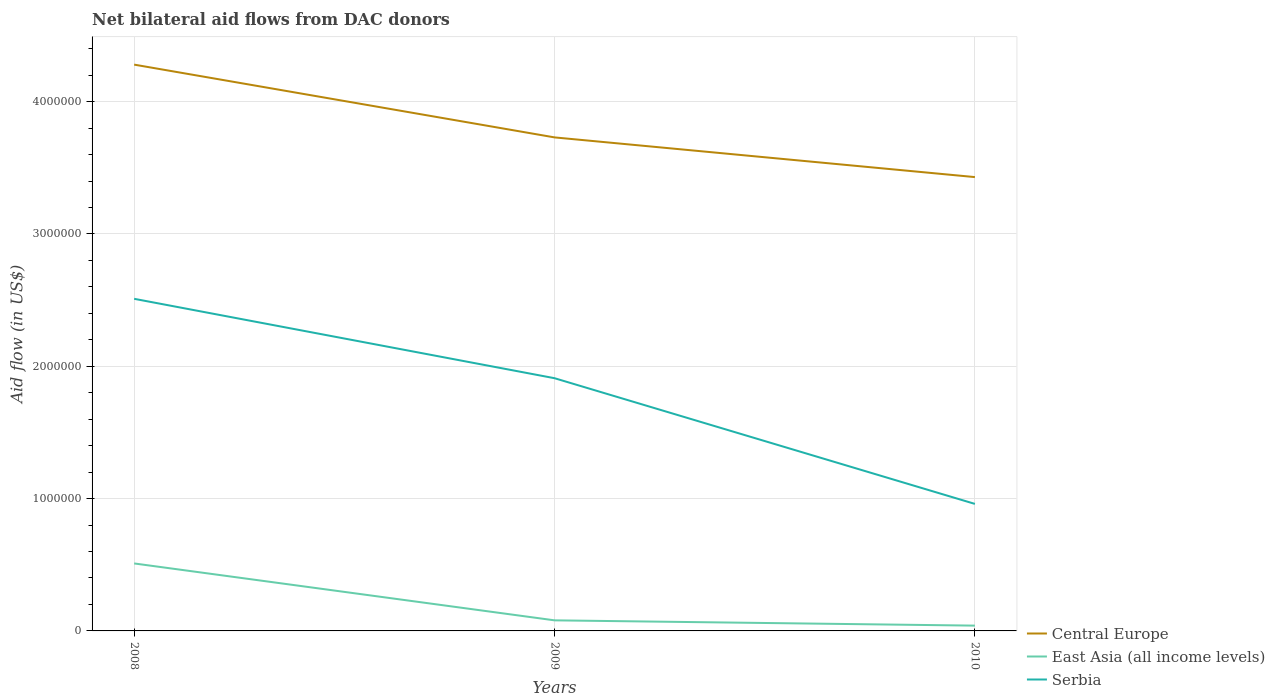Does the line corresponding to Serbia intersect with the line corresponding to Central Europe?
Your answer should be compact. No. Is the number of lines equal to the number of legend labels?
Your answer should be very brief. Yes. Across all years, what is the maximum net bilateral aid flow in Central Europe?
Provide a short and direct response. 3.43e+06. What is the total net bilateral aid flow in East Asia (all income levels) in the graph?
Provide a succinct answer. 4.30e+05. What is the difference between the highest and the second highest net bilateral aid flow in Central Europe?
Your response must be concise. 8.50e+05. How many lines are there?
Provide a succinct answer. 3. How many years are there in the graph?
Ensure brevity in your answer.  3. Are the values on the major ticks of Y-axis written in scientific E-notation?
Offer a terse response. No. Does the graph contain grids?
Your answer should be compact. Yes. What is the title of the graph?
Provide a succinct answer. Net bilateral aid flows from DAC donors. Does "Suriname" appear as one of the legend labels in the graph?
Offer a terse response. No. What is the label or title of the X-axis?
Offer a terse response. Years. What is the label or title of the Y-axis?
Ensure brevity in your answer.  Aid flow (in US$). What is the Aid flow (in US$) in Central Europe in 2008?
Offer a terse response. 4.28e+06. What is the Aid flow (in US$) of East Asia (all income levels) in 2008?
Your answer should be very brief. 5.10e+05. What is the Aid flow (in US$) of Serbia in 2008?
Ensure brevity in your answer.  2.51e+06. What is the Aid flow (in US$) of Central Europe in 2009?
Your answer should be very brief. 3.73e+06. What is the Aid flow (in US$) of East Asia (all income levels) in 2009?
Offer a very short reply. 8.00e+04. What is the Aid flow (in US$) in Serbia in 2009?
Keep it short and to the point. 1.91e+06. What is the Aid flow (in US$) of Central Europe in 2010?
Keep it short and to the point. 3.43e+06. What is the Aid flow (in US$) in East Asia (all income levels) in 2010?
Offer a very short reply. 4.00e+04. What is the Aid flow (in US$) of Serbia in 2010?
Offer a very short reply. 9.60e+05. Across all years, what is the maximum Aid flow (in US$) of Central Europe?
Provide a succinct answer. 4.28e+06. Across all years, what is the maximum Aid flow (in US$) of East Asia (all income levels)?
Ensure brevity in your answer.  5.10e+05. Across all years, what is the maximum Aid flow (in US$) in Serbia?
Provide a short and direct response. 2.51e+06. Across all years, what is the minimum Aid flow (in US$) in Central Europe?
Your response must be concise. 3.43e+06. Across all years, what is the minimum Aid flow (in US$) of Serbia?
Your response must be concise. 9.60e+05. What is the total Aid flow (in US$) in Central Europe in the graph?
Provide a succinct answer. 1.14e+07. What is the total Aid flow (in US$) of East Asia (all income levels) in the graph?
Keep it short and to the point. 6.30e+05. What is the total Aid flow (in US$) in Serbia in the graph?
Offer a terse response. 5.38e+06. What is the difference between the Aid flow (in US$) in Central Europe in 2008 and that in 2009?
Offer a very short reply. 5.50e+05. What is the difference between the Aid flow (in US$) of East Asia (all income levels) in 2008 and that in 2009?
Offer a very short reply. 4.30e+05. What is the difference between the Aid flow (in US$) in Central Europe in 2008 and that in 2010?
Your answer should be compact. 8.50e+05. What is the difference between the Aid flow (in US$) in Serbia in 2008 and that in 2010?
Provide a short and direct response. 1.55e+06. What is the difference between the Aid flow (in US$) in Central Europe in 2009 and that in 2010?
Ensure brevity in your answer.  3.00e+05. What is the difference between the Aid flow (in US$) of East Asia (all income levels) in 2009 and that in 2010?
Ensure brevity in your answer.  4.00e+04. What is the difference between the Aid flow (in US$) in Serbia in 2009 and that in 2010?
Your answer should be compact. 9.50e+05. What is the difference between the Aid flow (in US$) in Central Europe in 2008 and the Aid flow (in US$) in East Asia (all income levels) in 2009?
Offer a terse response. 4.20e+06. What is the difference between the Aid flow (in US$) in Central Europe in 2008 and the Aid flow (in US$) in Serbia in 2009?
Your response must be concise. 2.37e+06. What is the difference between the Aid flow (in US$) in East Asia (all income levels) in 2008 and the Aid flow (in US$) in Serbia in 2009?
Your response must be concise. -1.40e+06. What is the difference between the Aid flow (in US$) in Central Europe in 2008 and the Aid flow (in US$) in East Asia (all income levels) in 2010?
Your answer should be compact. 4.24e+06. What is the difference between the Aid flow (in US$) in Central Europe in 2008 and the Aid flow (in US$) in Serbia in 2010?
Your response must be concise. 3.32e+06. What is the difference between the Aid flow (in US$) of East Asia (all income levels) in 2008 and the Aid flow (in US$) of Serbia in 2010?
Your answer should be very brief. -4.50e+05. What is the difference between the Aid flow (in US$) of Central Europe in 2009 and the Aid flow (in US$) of East Asia (all income levels) in 2010?
Ensure brevity in your answer.  3.69e+06. What is the difference between the Aid flow (in US$) of Central Europe in 2009 and the Aid flow (in US$) of Serbia in 2010?
Provide a succinct answer. 2.77e+06. What is the difference between the Aid flow (in US$) in East Asia (all income levels) in 2009 and the Aid flow (in US$) in Serbia in 2010?
Provide a short and direct response. -8.80e+05. What is the average Aid flow (in US$) of Central Europe per year?
Your answer should be compact. 3.81e+06. What is the average Aid flow (in US$) of East Asia (all income levels) per year?
Offer a terse response. 2.10e+05. What is the average Aid flow (in US$) in Serbia per year?
Your answer should be compact. 1.79e+06. In the year 2008, what is the difference between the Aid flow (in US$) in Central Europe and Aid flow (in US$) in East Asia (all income levels)?
Keep it short and to the point. 3.77e+06. In the year 2008, what is the difference between the Aid flow (in US$) in Central Europe and Aid flow (in US$) in Serbia?
Offer a very short reply. 1.77e+06. In the year 2008, what is the difference between the Aid flow (in US$) in East Asia (all income levels) and Aid flow (in US$) in Serbia?
Make the answer very short. -2.00e+06. In the year 2009, what is the difference between the Aid flow (in US$) in Central Europe and Aid flow (in US$) in East Asia (all income levels)?
Your response must be concise. 3.65e+06. In the year 2009, what is the difference between the Aid flow (in US$) in Central Europe and Aid flow (in US$) in Serbia?
Keep it short and to the point. 1.82e+06. In the year 2009, what is the difference between the Aid flow (in US$) in East Asia (all income levels) and Aid flow (in US$) in Serbia?
Your answer should be compact. -1.83e+06. In the year 2010, what is the difference between the Aid flow (in US$) of Central Europe and Aid flow (in US$) of East Asia (all income levels)?
Your response must be concise. 3.39e+06. In the year 2010, what is the difference between the Aid flow (in US$) of Central Europe and Aid flow (in US$) of Serbia?
Provide a short and direct response. 2.47e+06. In the year 2010, what is the difference between the Aid flow (in US$) of East Asia (all income levels) and Aid flow (in US$) of Serbia?
Make the answer very short. -9.20e+05. What is the ratio of the Aid flow (in US$) in Central Europe in 2008 to that in 2009?
Keep it short and to the point. 1.15. What is the ratio of the Aid flow (in US$) in East Asia (all income levels) in 2008 to that in 2009?
Ensure brevity in your answer.  6.38. What is the ratio of the Aid flow (in US$) of Serbia in 2008 to that in 2009?
Your answer should be compact. 1.31. What is the ratio of the Aid flow (in US$) in Central Europe in 2008 to that in 2010?
Keep it short and to the point. 1.25. What is the ratio of the Aid flow (in US$) in East Asia (all income levels) in 2008 to that in 2010?
Ensure brevity in your answer.  12.75. What is the ratio of the Aid flow (in US$) of Serbia in 2008 to that in 2010?
Make the answer very short. 2.61. What is the ratio of the Aid flow (in US$) of Central Europe in 2009 to that in 2010?
Ensure brevity in your answer.  1.09. What is the ratio of the Aid flow (in US$) in Serbia in 2009 to that in 2010?
Provide a succinct answer. 1.99. What is the difference between the highest and the second highest Aid flow (in US$) in Central Europe?
Your response must be concise. 5.50e+05. What is the difference between the highest and the lowest Aid flow (in US$) in Central Europe?
Your answer should be compact. 8.50e+05. What is the difference between the highest and the lowest Aid flow (in US$) in East Asia (all income levels)?
Your response must be concise. 4.70e+05. What is the difference between the highest and the lowest Aid flow (in US$) in Serbia?
Keep it short and to the point. 1.55e+06. 